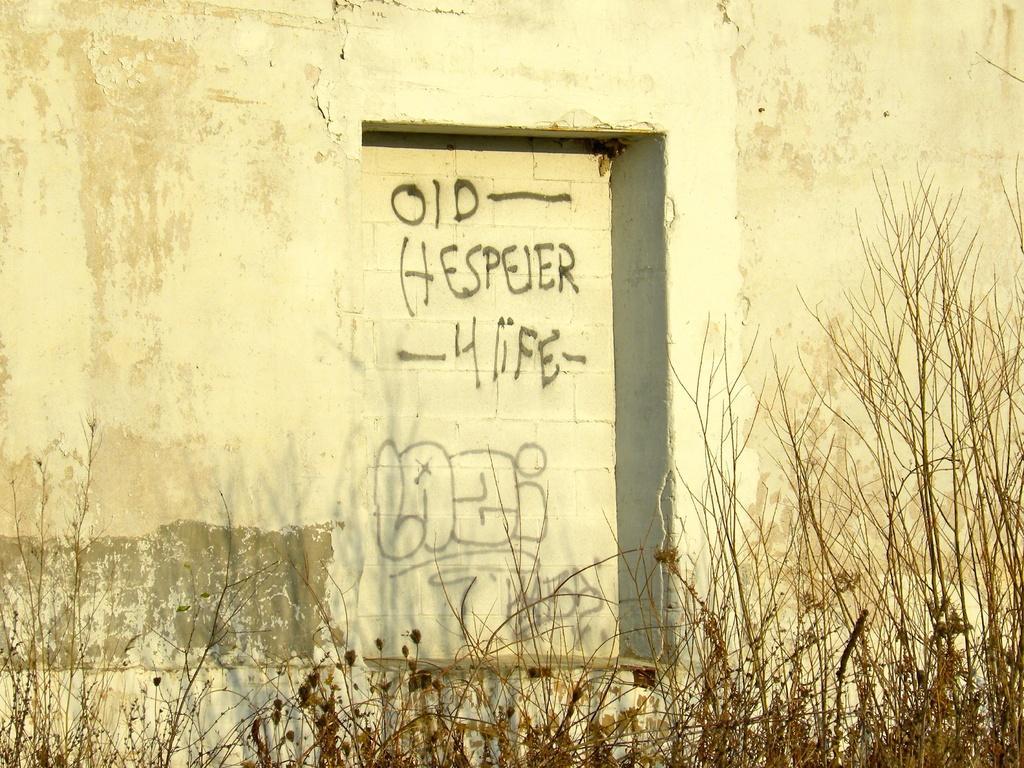Can you describe this image briefly? In this image I can see plants, a white colour wall and on this wall I can see something is written over here. 